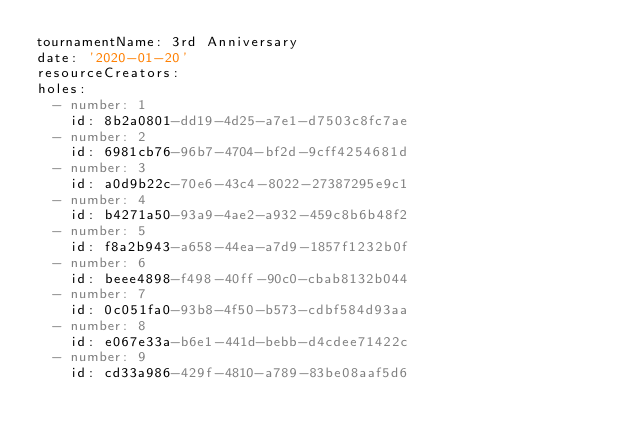Convert code to text. <code><loc_0><loc_0><loc_500><loc_500><_YAML_>tournamentName: 3rd Anniversary
date: '2020-01-20'
resourceCreators:
holes:
  - number: 1
    id: 8b2a0801-dd19-4d25-a7e1-d7503c8fc7ae
  - number: 2
    id: 6981cb76-96b7-4704-bf2d-9cff4254681d
  - number: 3
    id: a0d9b22c-70e6-43c4-8022-27387295e9c1
  - number: 4
    id: b4271a50-93a9-4ae2-a932-459c8b6b48f2
  - number: 5
    id: f8a2b943-a658-44ea-a7d9-1857f1232b0f
  - number: 6
    id: beee4898-f498-40ff-90c0-cbab8132b044
  - number: 7
    id: 0c051fa0-93b8-4f50-b573-cdbf584d93aa
  - number: 8
    id: e067e33a-b6e1-441d-bebb-d4cdee71422c
  - number: 9
    id: cd33a986-429f-4810-a789-83be08aaf5d6</code> 